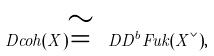<formula> <loc_0><loc_0><loc_500><loc_500>\ D c o h ( X ) \cong \ D D ^ { b } F u k ( X ^ { \vee } ) ,</formula> 